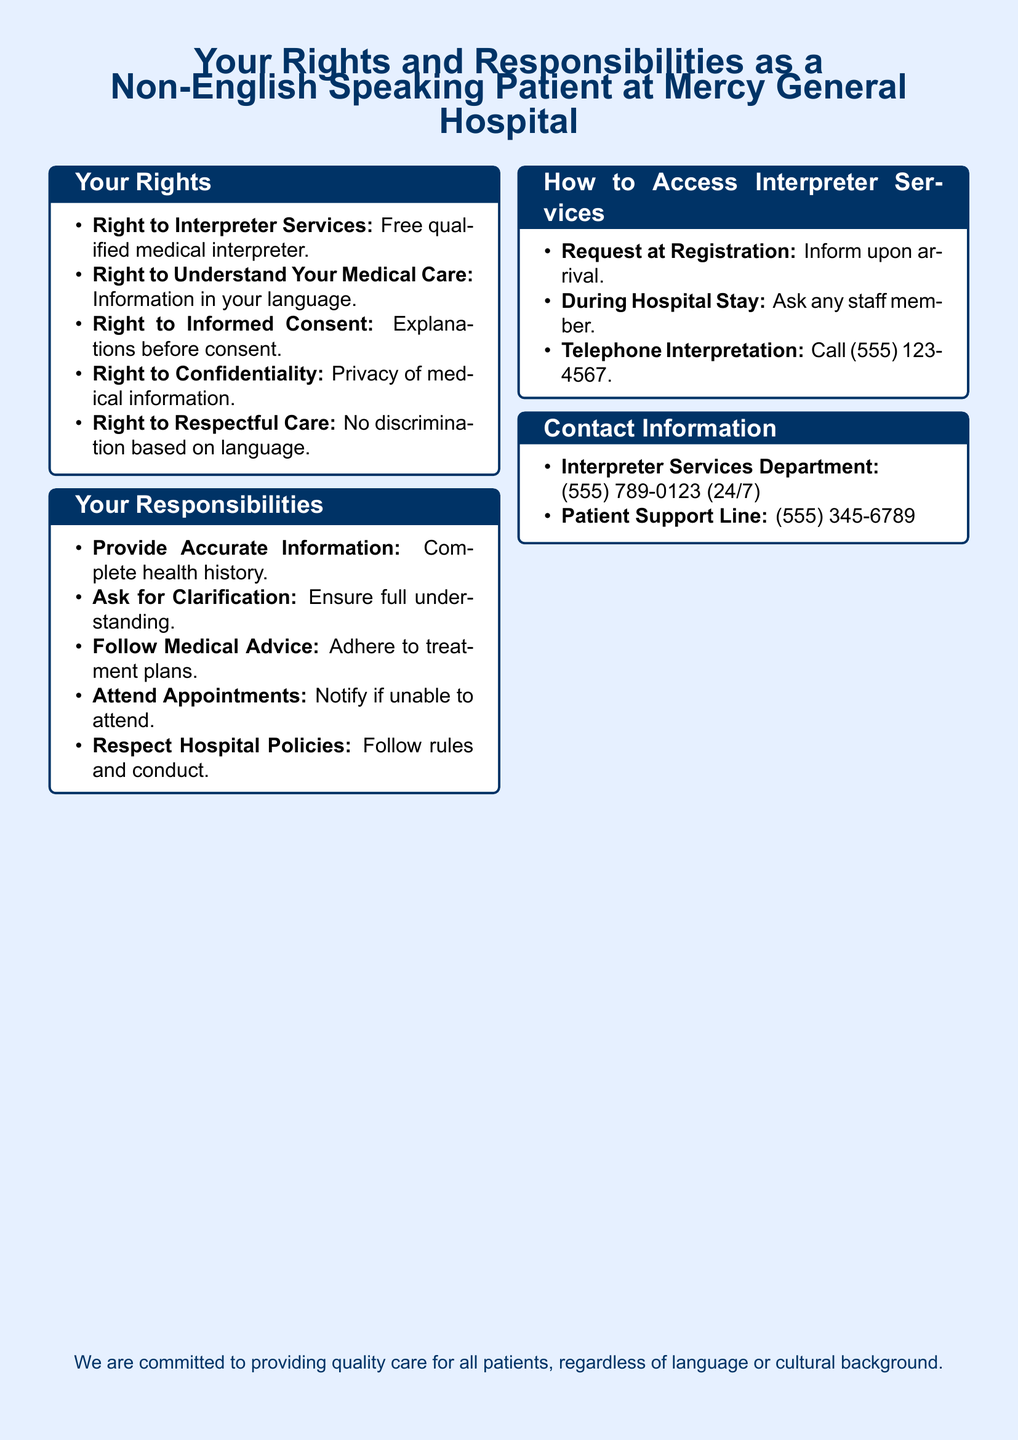What is the right to interpreter services? The right to interpreter services allows non-English speaking patients to receive free qualified medical interpretation.
Answer: Free qualified medical interpreter What number should you call for telephone interpretation? The document provides a specific phone number for telephone interpretation services, which is (555) 123-4567.
Answer: (555) 123-4567 How many responsibilities do non-English speaking patients have? The document lists several specific responsibilities for non-English speaking patients, totaling five distinct items.
Answer: Five What should patients provide for accurate information? Patients are expected to complete their health history accurately as part of their responsibilities.
Answer: Complete health history Which department can be contacted for interpreter services? The document mentions the Interpreter Services Department as the contact for interpreter services, with a provided phone number.
Answer: (555) 789-0123 